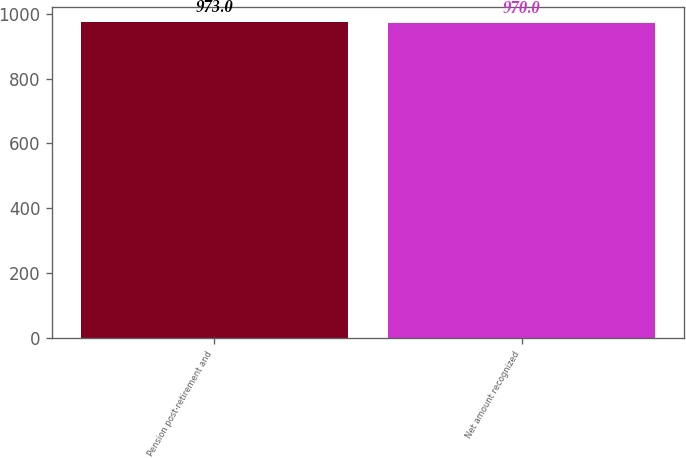<chart> <loc_0><loc_0><loc_500><loc_500><bar_chart><fcel>Pension post-retirement and<fcel>Net amount recognized<nl><fcel>973<fcel>970<nl></chart> 